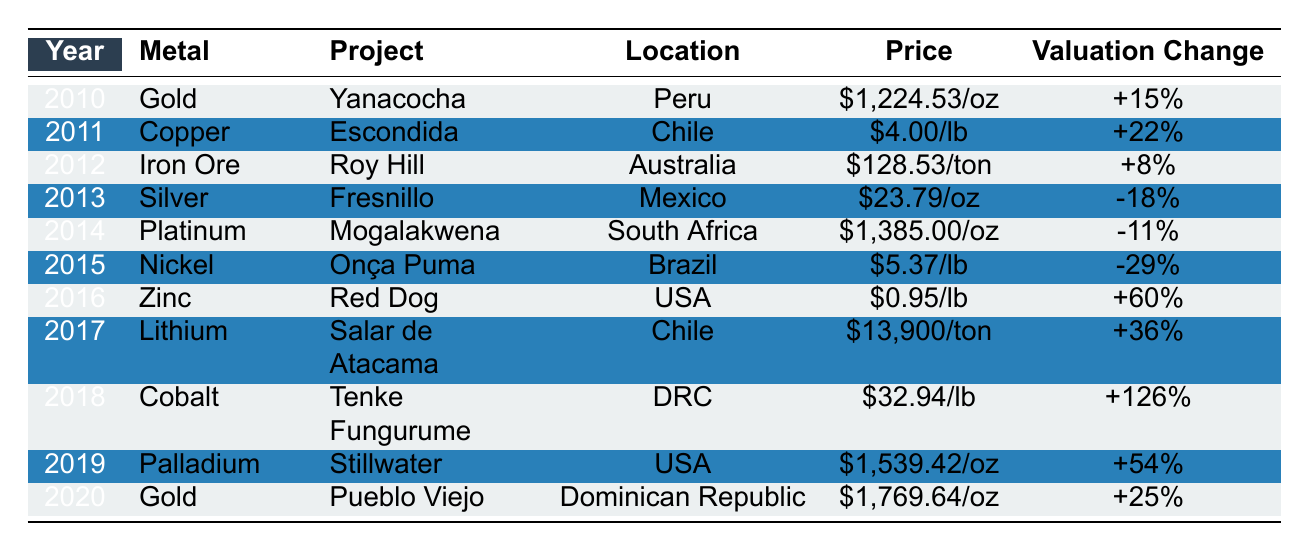What was the valuation change for the Onça Puma project? The table lists the valuation change for the Onça Puma project as -29%. This is found in the row corresponding to the year 2015, where the metal is Nickel.
Answer: -29% In which year did the Tenke Fungurume project see the highest valuation change? Looking at the table, the Tenke Fungurume project had a valuation change of +126% in 2018, which is the highest change listed among all projects.
Answer: 2018 What is the average price of Gold per ounce in the years listed? The prices for Gold in the years provided are $1,224.53 (2010) and $1,769.64 (2020). The average price is calculated as ($1,224.53 + $1,769.64) / 2 = $1,497.09.
Answer: $1,497.09 Did the valuation of the Zink project in 2016 increase or decrease compared to the previous year? The Zinc project in 2016 had a valuation change of +60%. The previous year (2015) the Onça Puma project had a valuation change of -29%. Since +60% is an increase and -29% is a decrease, the Zinc project improved significantly compared to the Onça Puma project's decline.
Answer: Increased Which metal had the biggest price per unit in the table? The price per unit amount for Lithium in 2017 is $13,900 per ton, which is the highest price compared to other metals listed in the table.
Answer: Lithium Out of the projects listed, which one experienced a negative valuation change and in which year? From the table, the projects that experienced negative valuation changes are Fresnillo in 2013 with -18%, Mogalakwena in 2014 with -11%, and Onça Puma in 2015 with -29%. Each of these projects is associated with their respective years listed.
Answer: Fresnillo (2013), Mogalakwena (2014), Onça Puma (2015) How many projects had valuation changes greater than +20%? Reviewing the table, the projects with valuation changes greater than +20% are Escondida (+22%), Zinc (+60%), Lithium (+36%), Cobalt (+126%), Palladium (+54%), Gold in 2020 (+25%). That results in a total of 6 projects.
Answer: 6 What was the year with the lowest price for Silver and what was that price? The table shows that the price for Silver in 2013 was $23.79 per ounce, and this is the only year listed for Silver, therefore, it is also the lowest price.
Answer: 2013, $23.79 Which project had the highest valuation change percentage and what year was it? The project with the highest valuation change percentage of +126% is Tenke Fungurume, which occurred in the year 2018 as seen in the table.
Answer: Tenke Fungurume, 2018 Has the overall trend for Gold valuation in the given years been positive or negative? The table reveals that Gold experienced a +15% change in 2010 and a +25% change in 2020. Thus, both years reflect positive trends for Gold valuation and the overall trend can be considered positive.
Answer: Positive Did Cobalt have a higher or lower valuation change compared to Iron Ore? Analyzing the table, Cobalt had a valuation change of +126% in 2018, while Iron Ore had a valuation change of +8% in 2012. Thus, Cobalt's change was significantly higher than that of Iron Ore.
Answer: Higher 